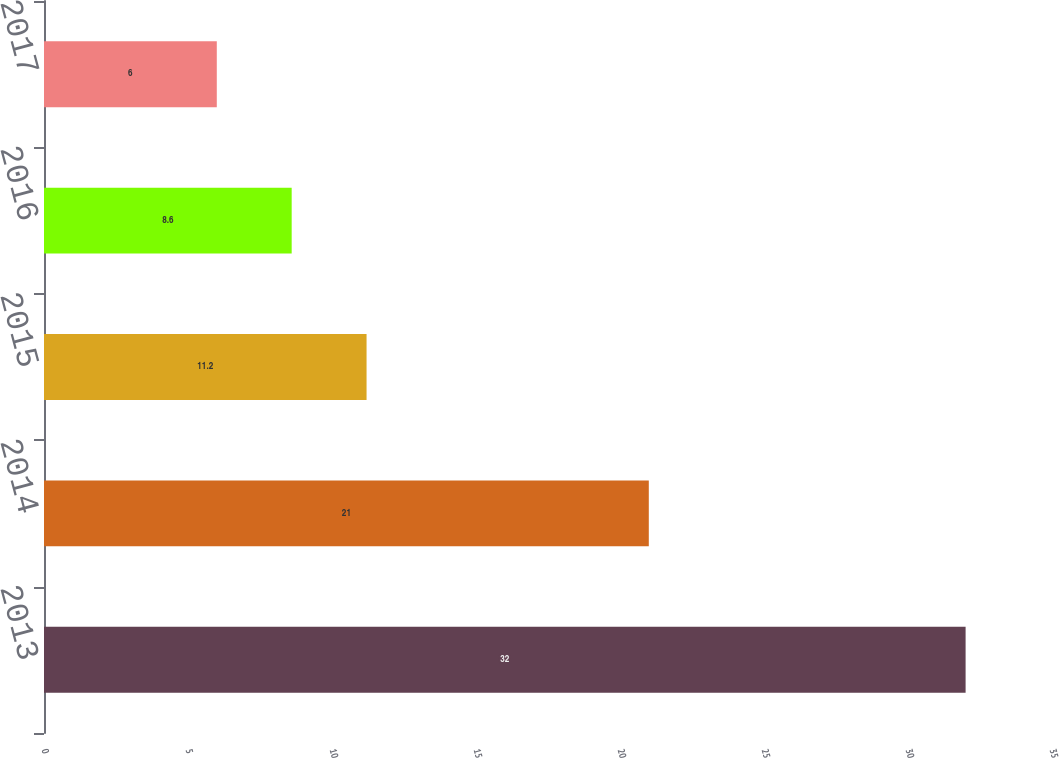Convert chart. <chart><loc_0><loc_0><loc_500><loc_500><bar_chart><fcel>2013<fcel>2014<fcel>2015<fcel>2016<fcel>2017<nl><fcel>32<fcel>21<fcel>11.2<fcel>8.6<fcel>6<nl></chart> 